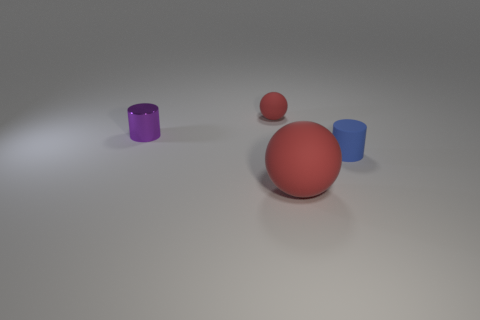Does this image seem to adhere to any specific design principles? Yes, the image demonstrates the design principles of balance and simplicity. The objects are arranged in a manner that feels stable and evenly spaced. The simplicity is achieved through the use of clean lines, smooth surfaces, and uncluttered composition, drawing attention to the shapes and colors of the objects. 